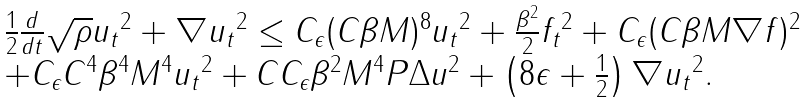Convert formula to latex. <formula><loc_0><loc_0><loc_500><loc_500>\begin{array} { l } \frac { 1 } { 2 } \frac { d } { d t } \| \sqrt { \rho } u _ { t } \| ^ { 2 } + \| \nabla u _ { t } \| ^ { 2 } \leq C _ { \epsilon } ( C \beta M ) ^ { 8 } \| u _ { t } \| ^ { 2 } + \frac { \beta ^ { 2 } } { 2 } \| f _ { t } \| ^ { 2 } + C _ { \epsilon } ( C \beta M \| \nabla f \| ) ^ { 2 } \\ + C _ { \epsilon } C ^ { 4 } \beta ^ { 4 } M ^ { 4 } \| u _ { t } \| ^ { 2 } + C C _ { \epsilon } \beta ^ { 2 } M ^ { 4 } \| P \Delta u \| ^ { 2 } + \left ( 8 \epsilon + \frac { 1 } { 2 } \right ) \| \nabla u _ { t } \| ^ { 2 } . \end{array}</formula> 